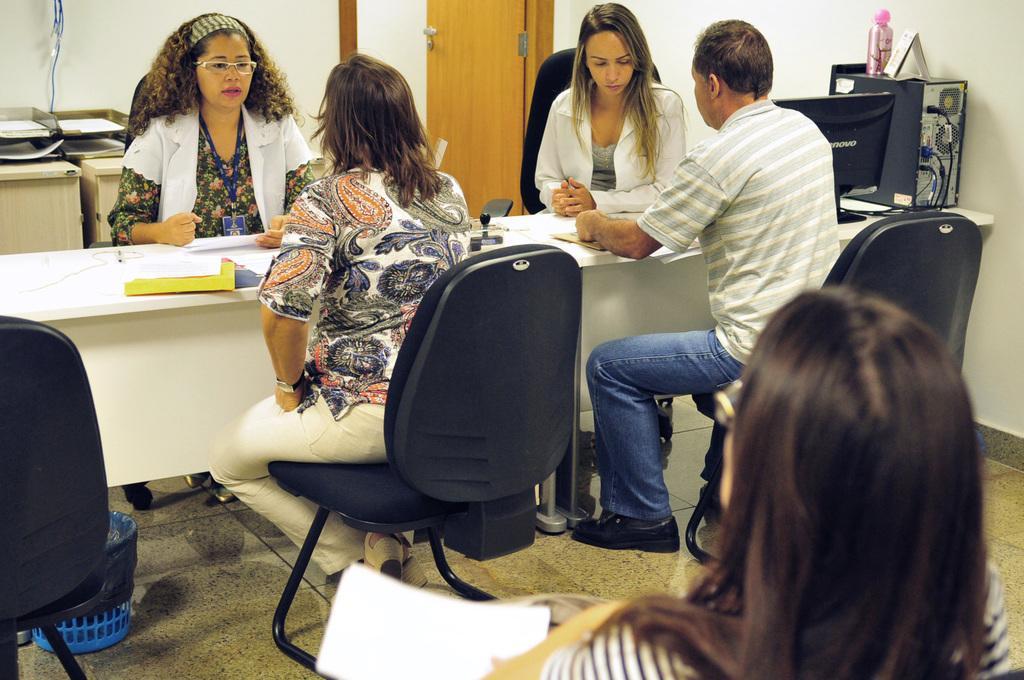Please provide a concise description of this image. Picture is taken in the room in which there are three woman and one man who are sitting in the chairs. There is a table in front of them. On the table there is a pen,book,paper and stamp. At the background there is door,wall and the table. At the bottom there is a dustbin,chairs. In the right side there is another woman who is sitting with the papers in her hand. 